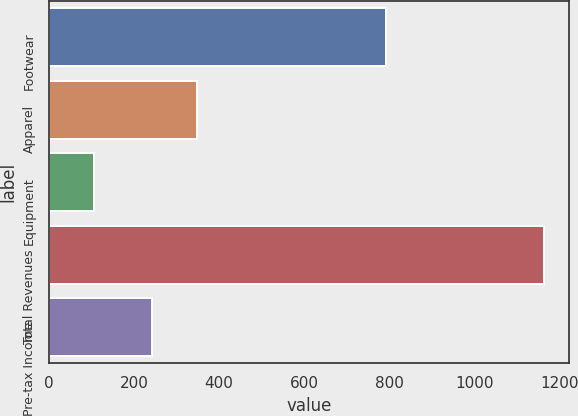<chart> <loc_0><loc_0><loc_500><loc_500><bar_chart><fcel>Footwear<fcel>Apparel<fcel>Equipment<fcel>Total Revenues<fcel>Pre-tax Income<nl><fcel>792.7<fcel>348.11<fcel>106.6<fcel>1164.7<fcel>242.3<nl></chart> 